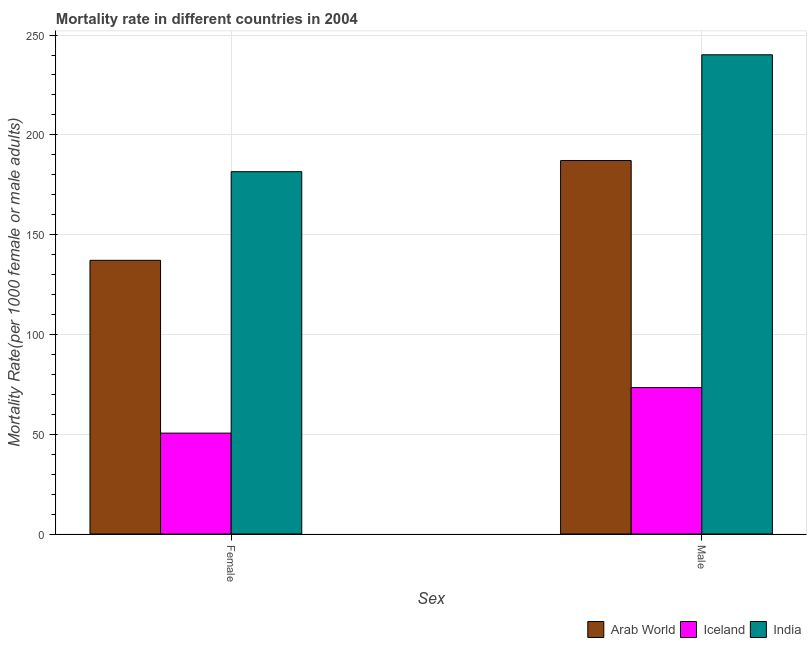How many different coloured bars are there?
Provide a short and direct response. 3. How many groups of bars are there?
Your response must be concise. 2. How many bars are there on the 2nd tick from the left?
Your answer should be compact. 3. How many bars are there on the 1st tick from the right?
Make the answer very short. 3. What is the female mortality rate in Iceland?
Provide a short and direct response. 50.55. Across all countries, what is the maximum male mortality rate?
Your response must be concise. 240.12. Across all countries, what is the minimum female mortality rate?
Give a very brief answer. 50.55. In which country was the female mortality rate maximum?
Ensure brevity in your answer.  India. What is the total male mortality rate in the graph?
Your answer should be very brief. 500.62. What is the difference between the female mortality rate in Iceland and that in Arab World?
Your answer should be compact. -86.58. What is the difference between the male mortality rate in India and the female mortality rate in Iceland?
Offer a terse response. 189.57. What is the average female mortality rate per country?
Offer a very short reply. 123.08. What is the difference between the female mortality rate and male mortality rate in Arab World?
Provide a short and direct response. -50. In how many countries, is the male mortality rate greater than 30 ?
Make the answer very short. 3. What is the ratio of the female mortality rate in Arab World to that in India?
Your answer should be very brief. 0.76. What does the 3rd bar from the right in Female represents?
Your answer should be compact. Arab World. How many bars are there?
Offer a very short reply. 6. Are all the bars in the graph horizontal?
Offer a terse response. No. What is the title of the graph?
Your response must be concise. Mortality rate in different countries in 2004. Does "Bhutan" appear as one of the legend labels in the graph?
Provide a short and direct response. No. What is the label or title of the X-axis?
Provide a short and direct response. Sex. What is the label or title of the Y-axis?
Your response must be concise. Mortality Rate(per 1000 female or male adults). What is the Mortality Rate(per 1000 female or male adults) in Arab World in Female?
Your response must be concise. 137.14. What is the Mortality Rate(per 1000 female or male adults) of Iceland in Female?
Offer a very short reply. 50.55. What is the Mortality Rate(per 1000 female or male adults) in India in Female?
Offer a terse response. 181.55. What is the Mortality Rate(per 1000 female or male adults) in Arab World in Male?
Your answer should be very brief. 187.13. What is the Mortality Rate(per 1000 female or male adults) in Iceland in Male?
Make the answer very short. 73.37. What is the Mortality Rate(per 1000 female or male adults) of India in Male?
Provide a succinct answer. 240.12. Across all Sex, what is the maximum Mortality Rate(per 1000 female or male adults) of Arab World?
Ensure brevity in your answer.  187.13. Across all Sex, what is the maximum Mortality Rate(per 1000 female or male adults) of Iceland?
Keep it short and to the point. 73.37. Across all Sex, what is the maximum Mortality Rate(per 1000 female or male adults) in India?
Offer a terse response. 240.12. Across all Sex, what is the minimum Mortality Rate(per 1000 female or male adults) in Arab World?
Offer a terse response. 137.14. Across all Sex, what is the minimum Mortality Rate(per 1000 female or male adults) in Iceland?
Make the answer very short. 50.55. Across all Sex, what is the minimum Mortality Rate(per 1000 female or male adults) of India?
Provide a short and direct response. 181.55. What is the total Mortality Rate(per 1000 female or male adults) in Arab World in the graph?
Your answer should be compact. 324.27. What is the total Mortality Rate(per 1000 female or male adults) of Iceland in the graph?
Offer a terse response. 123.92. What is the total Mortality Rate(per 1000 female or male adults) in India in the graph?
Offer a very short reply. 421.68. What is the difference between the Mortality Rate(per 1000 female or male adults) in Arab World in Female and that in Male?
Keep it short and to the point. -50. What is the difference between the Mortality Rate(per 1000 female or male adults) of Iceland in Female and that in Male?
Provide a short and direct response. -22.81. What is the difference between the Mortality Rate(per 1000 female or male adults) of India in Female and that in Male?
Keep it short and to the point. -58.57. What is the difference between the Mortality Rate(per 1000 female or male adults) in Arab World in Female and the Mortality Rate(per 1000 female or male adults) in Iceland in Male?
Provide a short and direct response. 63.77. What is the difference between the Mortality Rate(per 1000 female or male adults) of Arab World in Female and the Mortality Rate(per 1000 female or male adults) of India in Male?
Your answer should be very brief. -102.99. What is the difference between the Mortality Rate(per 1000 female or male adults) of Iceland in Female and the Mortality Rate(per 1000 female or male adults) of India in Male?
Offer a very short reply. -189.57. What is the average Mortality Rate(per 1000 female or male adults) of Arab World per Sex?
Your response must be concise. 162.14. What is the average Mortality Rate(per 1000 female or male adults) in Iceland per Sex?
Keep it short and to the point. 61.96. What is the average Mortality Rate(per 1000 female or male adults) in India per Sex?
Keep it short and to the point. 210.84. What is the difference between the Mortality Rate(per 1000 female or male adults) of Arab World and Mortality Rate(per 1000 female or male adults) of Iceland in Female?
Your answer should be compact. 86.58. What is the difference between the Mortality Rate(per 1000 female or male adults) in Arab World and Mortality Rate(per 1000 female or male adults) in India in Female?
Provide a succinct answer. -44.41. What is the difference between the Mortality Rate(per 1000 female or male adults) in Iceland and Mortality Rate(per 1000 female or male adults) in India in Female?
Provide a succinct answer. -131. What is the difference between the Mortality Rate(per 1000 female or male adults) of Arab World and Mortality Rate(per 1000 female or male adults) of Iceland in Male?
Make the answer very short. 113.77. What is the difference between the Mortality Rate(per 1000 female or male adults) of Arab World and Mortality Rate(per 1000 female or male adults) of India in Male?
Provide a short and direct response. -52.99. What is the difference between the Mortality Rate(per 1000 female or male adults) in Iceland and Mortality Rate(per 1000 female or male adults) in India in Male?
Offer a very short reply. -166.76. What is the ratio of the Mortality Rate(per 1000 female or male adults) in Arab World in Female to that in Male?
Keep it short and to the point. 0.73. What is the ratio of the Mortality Rate(per 1000 female or male adults) in Iceland in Female to that in Male?
Your response must be concise. 0.69. What is the ratio of the Mortality Rate(per 1000 female or male adults) of India in Female to that in Male?
Your answer should be very brief. 0.76. What is the difference between the highest and the second highest Mortality Rate(per 1000 female or male adults) of Arab World?
Offer a very short reply. 50. What is the difference between the highest and the second highest Mortality Rate(per 1000 female or male adults) in Iceland?
Offer a terse response. 22.81. What is the difference between the highest and the second highest Mortality Rate(per 1000 female or male adults) in India?
Your answer should be compact. 58.57. What is the difference between the highest and the lowest Mortality Rate(per 1000 female or male adults) in Arab World?
Your response must be concise. 50. What is the difference between the highest and the lowest Mortality Rate(per 1000 female or male adults) of Iceland?
Your answer should be compact. 22.81. What is the difference between the highest and the lowest Mortality Rate(per 1000 female or male adults) in India?
Provide a short and direct response. 58.57. 